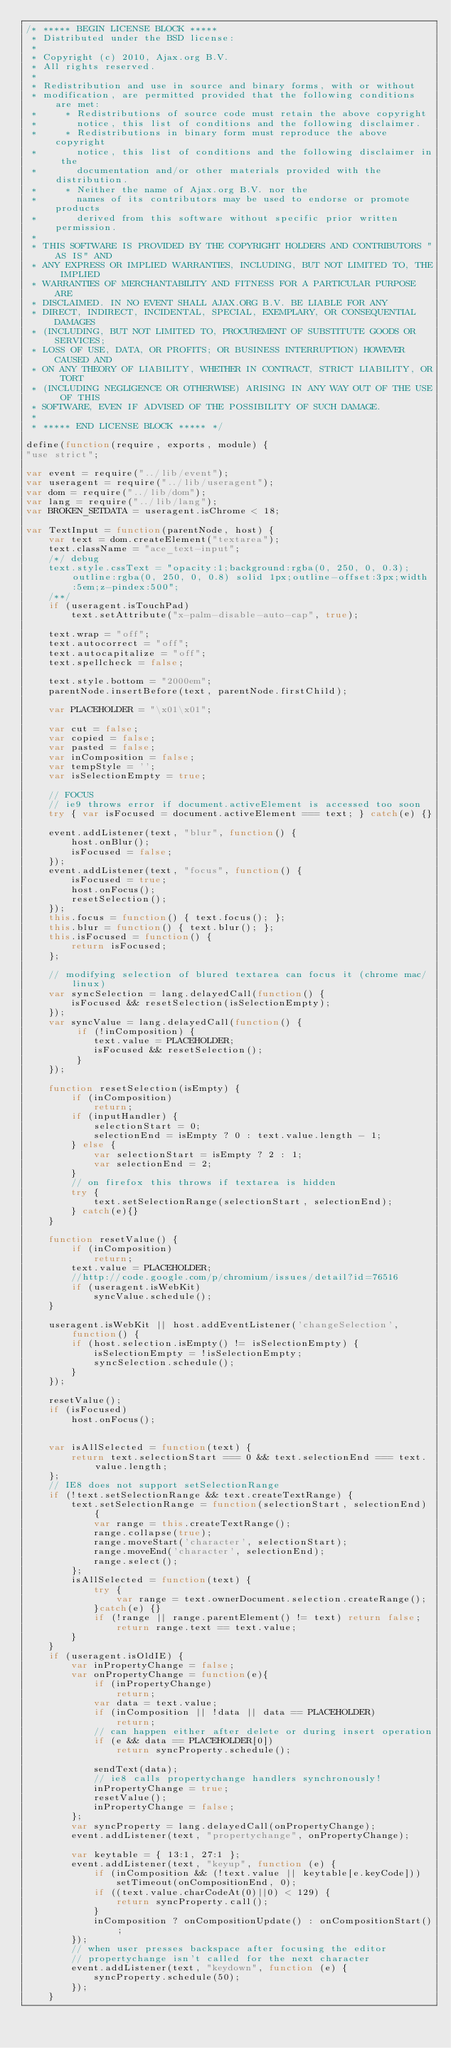Convert code to text. <code><loc_0><loc_0><loc_500><loc_500><_JavaScript_>/* ***** BEGIN LICENSE BLOCK *****
 * Distributed under the BSD license:
 *
 * Copyright (c) 2010, Ajax.org B.V.
 * All rights reserved.
 *
 * Redistribution and use in source and binary forms, with or without
 * modification, are permitted provided that the following conditions are met:
 *     * Redistributions of source code must retain the above copyright
 *       notice, this list of conditions and the following disclaimer.
 *     * Redistributions in binary form must reproduce the above copyright
 *       notice, this list of conditions and the following disclaimer in the
 *       documentation and/or other materials provided with the distribution.
 *     * Neither the name of Ajax.org B.V. nor the
 *       names of its contributors may be used to endorse or promote products
 *       derived from this software without specific prior written permission.
 *
 * THIS SOFTWARE IS PROVIDED BY THE COPYRIGHT HOLDERS AND CONTRIBUTORS "AS IS" AND
 * ANY EXPRESS OR IMPLIED WARRANTIES, INCLUDING, BUT NOT LIMITED TO, THE IMPLIED
 * WARRANTIES OF MERCHANTABILITY AND FITNESS FOR A PARTICULAR PURPOSE ARE
 * DISCLAIMED. IN NO EVENT SHALL AJAX.ORG B.V. BE LIABLE FOR ANY
 * DIRECT, INDIRECT, INCIDENTAL, SPECIAL, EXEMPLARY, OR CONSEQUENTIAL DAMAGES
 * (INCLUDING, BUT NOT LIMITED TO, PROCUREMENT OF SUBSTITUTE GOODS OR SERVICES;
 * LOSS OF USE, DATA, OR PROFITS; OR BUSINESS INTERRUPTION) HOWEVER CAUSED AND
 * ON ANY THEORY OF LIABILITY, WHETHER IN CONTRACT, STRICT LIABILITY, OR TORT
 * (INCLUDING NEGLIGENCE OR OTHERWISE) ARISING IN ANY WAY OUT OF THE USE OF THIS
 * SOFTWARE, EVEN IF ADVISED OF THE POSSIBILITY OF SUCH DAMAGE.
 *
 * ***** END LICENSE BLOCK ***** */

define(function(require, exports, module) {
"use strict";

var event = require("../lib/event");
var useragent = require("../lib/useragent");
var dom = require("../lib/dom");
var lang = require("../lib/lang");
var BROKEN_SETDATA = useragent.isChrome < 18;

var TextInput = function(parentNode, host) {
    var text = dom.createElement("textarea");
    text.className = "ace_text-input";
    /*/ debug
    text.style.cssText = "opacity:1;background:rgba(0, 250, 0, 0.3);outline:rgba(0, 250, 0, 0.8) solid 1px;outline-offset:3px;width:5em;z-pindex:500";
    /**/
    if (useragent.isTouchPad)
        text.setAttribute("x-palm-disable-auto-cap", true);

    text.wrap = "off";
    text.autocorrect = "off";
    text.autocapitalize = "off";
    text.spellcheck = false;

    text.style.bottom = "2000em";
    parentNode.insertBefore(text, parentNode.firstChild);

    var PLACEHOLDER = "\x01\x01";

    var cut = false;
    var copied = false;
    var pasted = false;
    var inComposition = false;
    var tempStyle = '';
    var isSelectionEmpty = true;

    // FOCUS
    // ie9 throws error if document.activeElement is accessed too soon
    try { var isFocused = document.activeElement === text; } catch(e) {}
    
    event.addListener(text, "blur", function() {
        host.onBlur();
        isFocused = false;
    });
    event.addListener(text, "focus", function() {
        isFocused = true;
        host.onFocus();
        resetSelection();
    });
    this.focus = function() { text.focus(); };
    this.blur = function() { text.blur(); };
    this.isFocused = function() {
        return isFocused;
    };

    // modifying selection of blured textarea can focus it (chrome mac/linux)
    var syncSelection = lang.delayedCall(function() {
        isFocused && resetSelection(isSelectionEmpty);
    });
    var syncValue = lang.delayedCall(function() {
         if (!inComposition) {
            text.value = PLACEHOLDER;
            isFocused && resetSelection();
         }
    });

    function resetSelection(isEmpty) {
        if (inComposition)
            return;
        if (inputHandler) {
            selectionStart = 0;
            selectionEnd = isEmpty ? 0 : text.value.length - 1;
        } else {
            var selectionStart = isEmpty ? 2 : 1;
            var selectionEnd = 2;
        }
        // on firefox this throws if textarea is hidden
        try {
            text.setSelectionRange(selectionStart, selectionEnd);
        } catch(e){}
    }

    function resetValue() {
        if (inComposition)
            return;
        text.value = PLACEHOLDER;
        //http://code.google.com/p/chromium/issues/detail?id=76516
        if (useragent.isWebKit)
            syncValue.schedule();
    }

    useragent.isWebKit || host.addEventListener('changeSelection', function() {
        if (host.selection.isEmpty() != isSelectionEmpty) {
            isSelectionEmpty = !isSelectionEmpty;
            syncSelection.schedule();
        }
    });

    resetValue();
    if (isFocused)
        host.onFocus();


    var isAllSelected = function(text) {
        return text.selectionStart === 0 && text.selectionEnd === text.value.length;
    };
    // IE8 does not support setSelectionRange
    if (!text.setSelectionRange && text.createTextRange) {
        text.setSelectionRange = function(selectionStart, selectionEnd) {
            var range = this.createTextRange();
            range.collapse(true);
            range.moveStart('character', selectionStart);
            range.moveEnd('character', selectionEnd);
            range.select();
        };
        isAllSelected = function(text) {
            try {
                var range = text.ownerDocument.selection.createRange();
            }catch(e) {}
            if (!range || range.parentElement() != text) return false;
                return range.text == text.value;
        }
    }
    if (useragent.isOldIE) {
        var inPropertyChange = false;
        var onPropertyChange = function(e){
            if (inPropertyChange)
                return;
            var data = text.value;
            if (inComposition || !data || data == PLACEHOLDER)
                return;
            // can happen either after delete or during insert operation
            if (e && data == PLACEHOLDER[0])
                return syncProperty.schedule();

            sendText(data);
            // ie8 calls propertychange handlers synchronously!
            inPropertyChange = true;
            resetValue();
            inPropertyChange = false;
        };
        var syncProperty = lang.delayedCall(onPropertyChange);
        event.addListener(text, "propertychange", onPropertyChange);

        var keytable = { 13:1, 27:1 };
        event.addListener(text, "keyup", function (e) {
            if (inComposition && (!text.value || keytable[e.keyCode]))
                setTimeout(onCompositionEnd, 0);
            if ((text.value.charCodeAt(0)||0) < 129) {
                return syncProperty.call();
            }
            inComposition ? onCompositionUpdate() : onCompositionStart();
        });
        // when user presses backspace after focusing the editor 
        // propertychange isn't called for the next character
        event.addListener(text, "keydown", function (e) {
            syncProperty.schedule(50);
        });
    }
</code> 